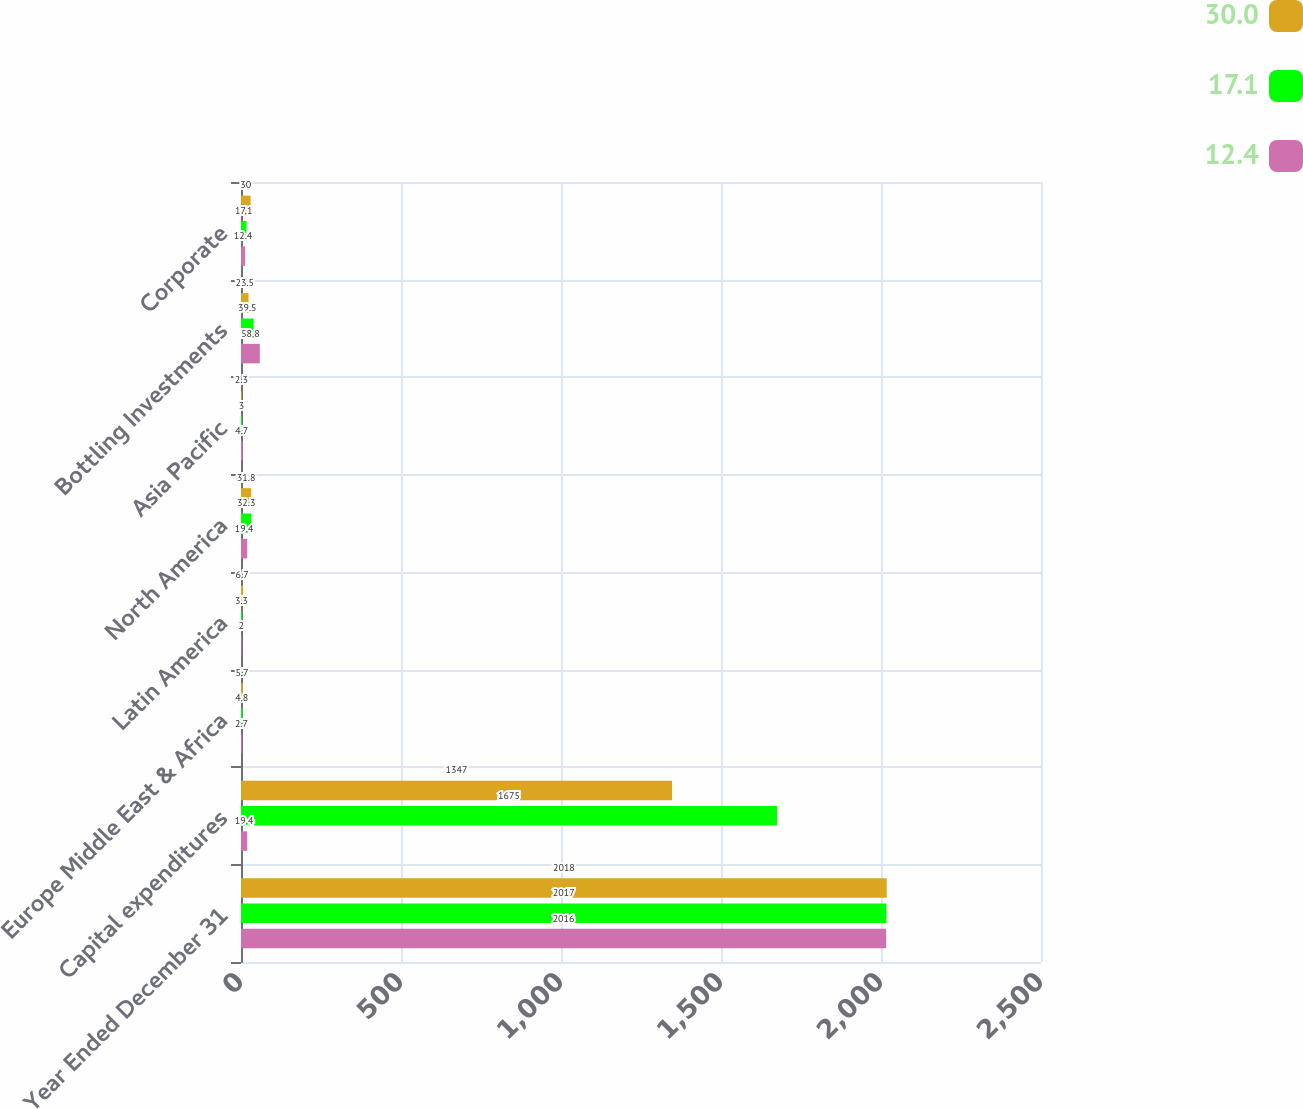<chart> <loc_0><loc_0><loc_500><loc_500><stacked_bar_chart><ecel><fcel>Year Ended December 31<fcel>Capital expenditures<fcel>Europe Middle East & Africa<fcel>Latin America<fcel>North America<fcel>Asia Pacific<fcel>Bottling Investments<fcel>Corporate<nl><fcel>30<fcel>2018<fcel>1347<fcel>5.7<fcel>6.7<fcel>31.8<fcel>2.3<fcel>23.5<fcel>30<nl><fcel>17.1<fcel>2017<fcel>1675<fcel>4.8<fcel>3.3<fcel>32.3<fcel>3<fcel>39.5<fcel>17.1<nl><fcel>12.4<fcel>2016<fcel>19.4<fcel>2.7<fcel>2<fcel>19.4<fcel>4.7<fcel>58.8<fcel>12.4<nl></chart> 